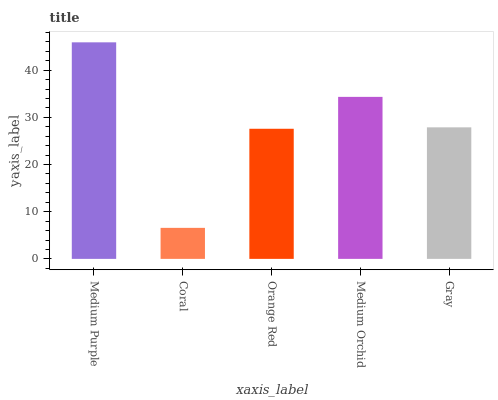Is Orange Red the minimum?
Answer yes or no. No. Is Orange Red the maximum?
Answer yes or no. No. Is Orange Red greater than Coral?
Answer yes or no. Yes. Is Coral less than Orange Red?
Answer yes or no. Yes. Is Coral greater than Orange Red?
Answer yes or no. No. Is Orange Red less than Coral?
Answer yes or no. No. Is Gray the high median?
Answer yes or no. Yes. Is Gray the low median?
Answer yes or no. Yes. Is Orange Red the high median?
Answer yes or no. No. Is Medium Purple the low median?
Answer yes or no. No. 